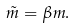Convert formula to latex. <formula><loc_0><loc_0><loc_500><loc_500>\tilde { m } = \beta m .</formula> 